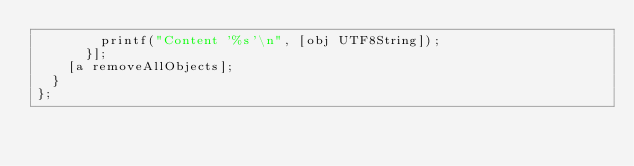Convert code to text. <code><loc_0><loc_0><loc_500><loc_500><_ObjectiveC_>				printf("Content '%s'\n", [obj UTF8String]);
			}];
		[a removeAllObjects];
	}
};
</code> 